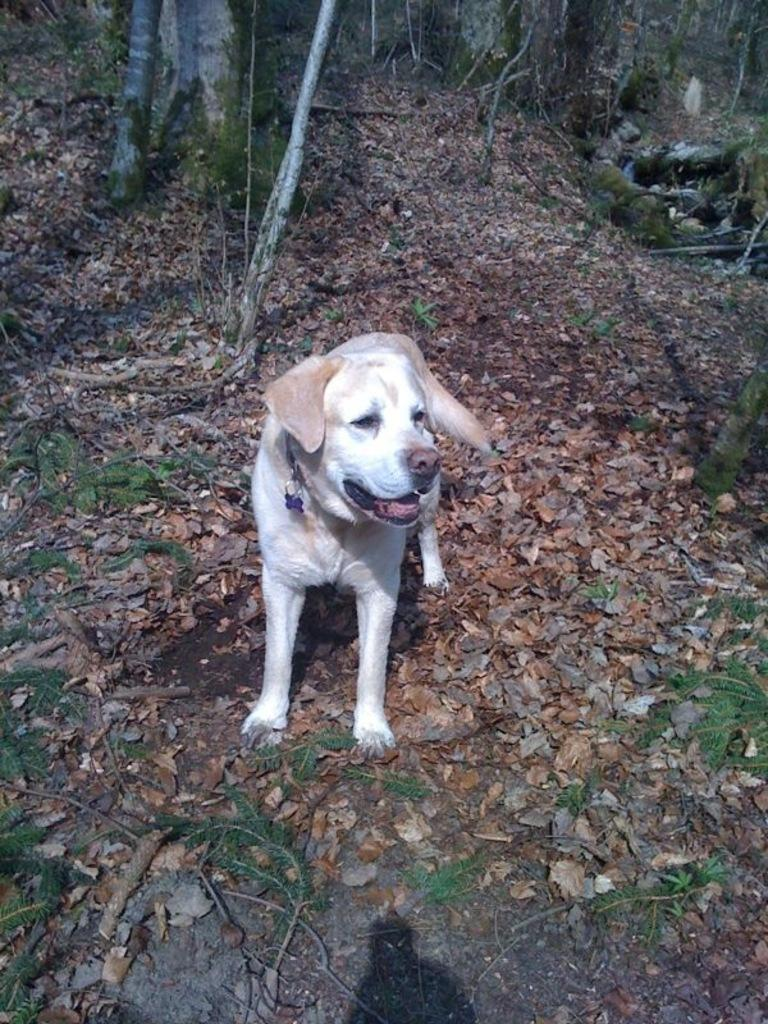What is the main subject in the center of the image? There is a dog in the center of the image. What can be seen in the background of the image? There are trees in the background of the image. What is present at the bottom of the image? Dry leaves and plants are present at the bottom of the image. How much money is the dog holding in the image? The dog is not holding any money in the image. There is no money present. 